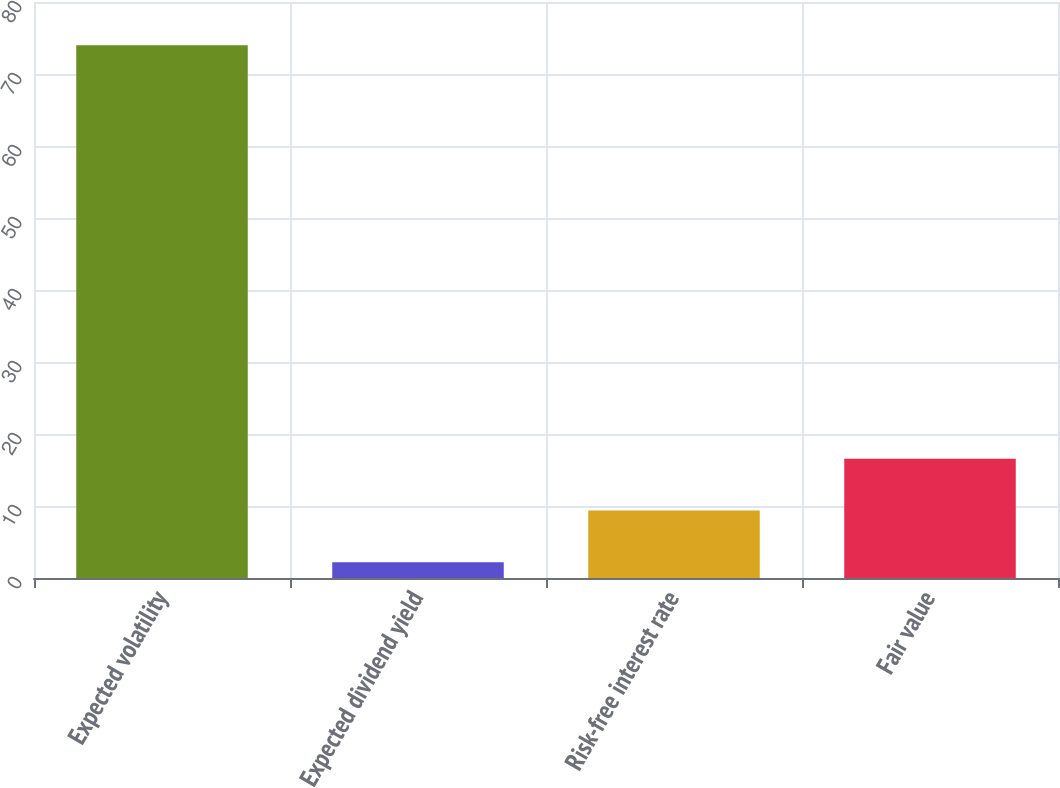Convert chart to OTSL. <chart><loc_0><loc_0><loc_500><loc_500><bar_chart><fcel>Expected volatility<fcel>Expected dividend yield<fcel>Risk-free interest rate<fcel>Fair value<nl><fcel>74<fcel>2.2<fcel>9.38<fcel>16.56<nl></chart> 